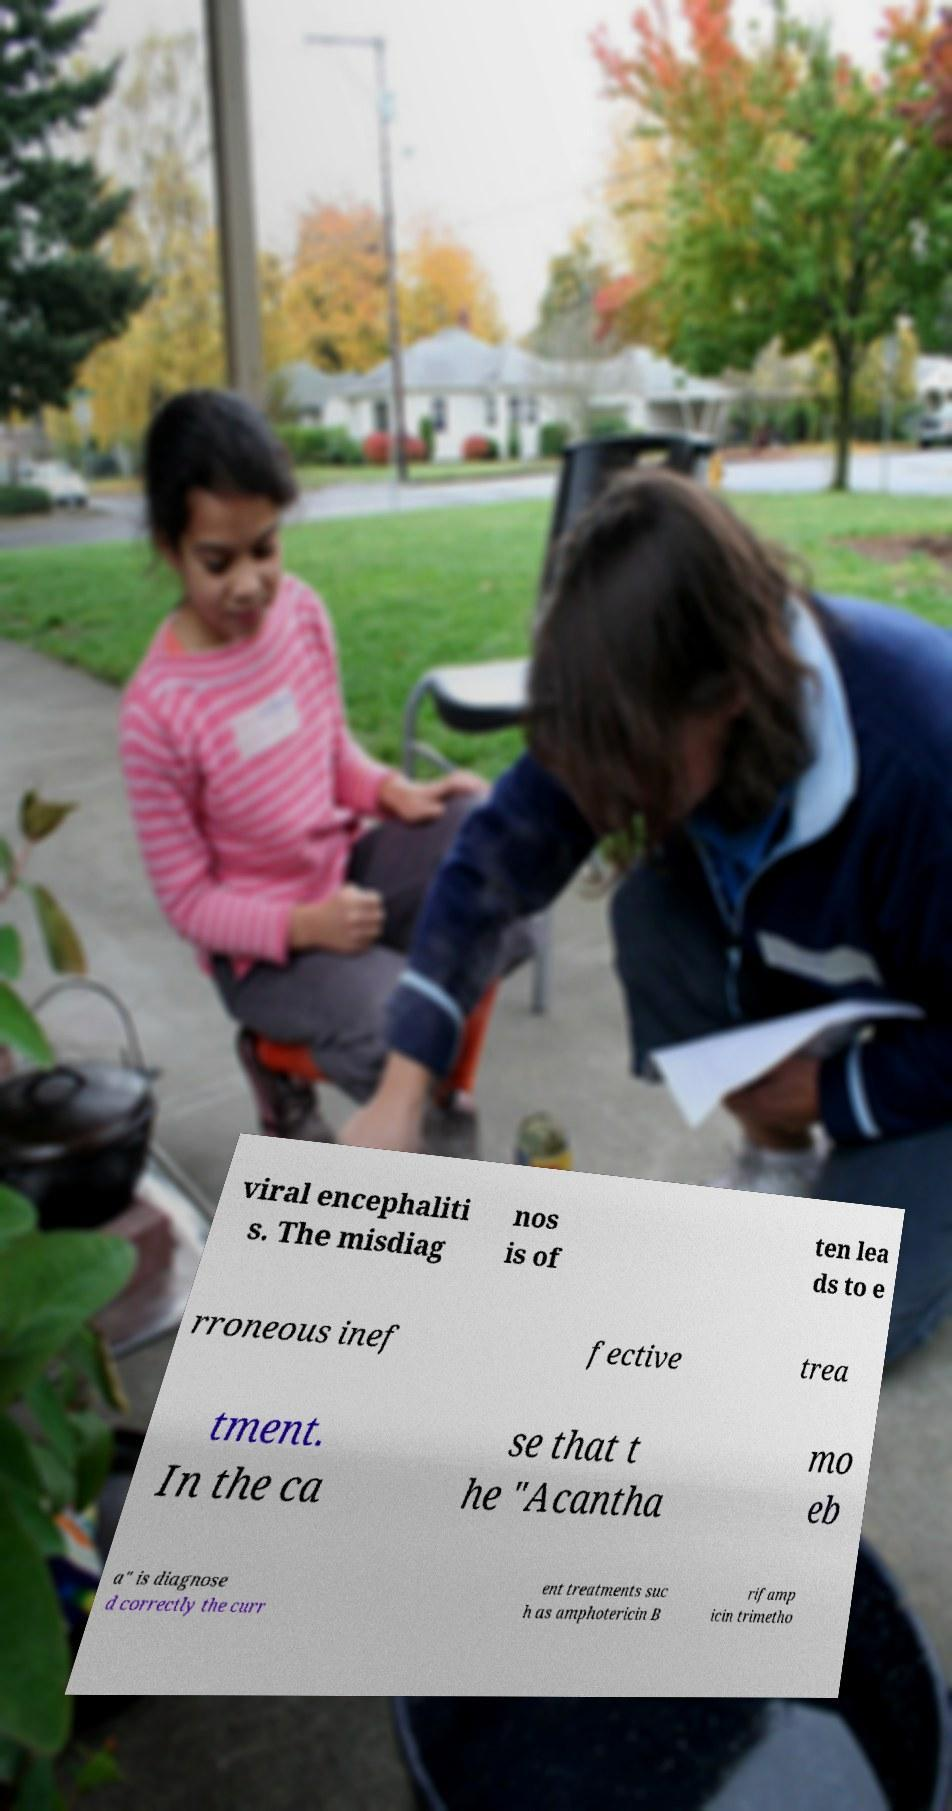Please read and relay the text visible in this image. What does it say? viral encephaliti s. The misdiag nos is of ten lea ds to e rroneous inef fective trea tment. In the ca se that t he "Acantha mo eb a" is diagnose d correctly the curr ent treatments suc h as amphotericin B rifamp icin trimetho 